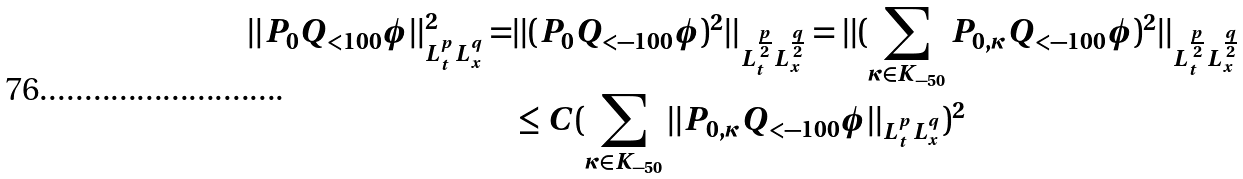Convert formula to latex. <formula><loc_0><loc_0><loc_500><loc_500>| | P _ { 0 } Q _ { < 1 0 0 } \phi | | _ { L _ { t } ^ { p } L _ { x } ^ { q } } ^ { 2 } = & | | ( P _ { 0 } Q _ { < - 1 0 0 } \phi ) ^ { 2 } | | _ { L _ { t } ^ { \frac { p } { 2 } } L _ { x } ^ { \frac { q } { 2 } } } = | | ( \sum _ { \kappa \in K _ { - 5 0 } } P _ { 0 , \kappa } Q _ { < - 1 0 0 } \phi ) ^ { 2 } | | _ { L _ { t } ^ { \frac { p } { 2 } } L _ { x } ^ { \frac { q } { 2 } } } \\ & \leq C ( \sum _ { \kappa \in K _ { - 5 0 } } | | P _ { 0 , \kappa } Q _ { < - 1 0 0 } \phi | | _ { L _ { t } ^ { p } L _ { x } ^ { q } } ) ^ { 2 } \\</formula> 